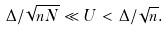<formula> <loc_0><loc_0><loc_500><loc_500>\Delta / \sqrt { n N } \ll U < \Delta / \sqrt { n } .</formula> 